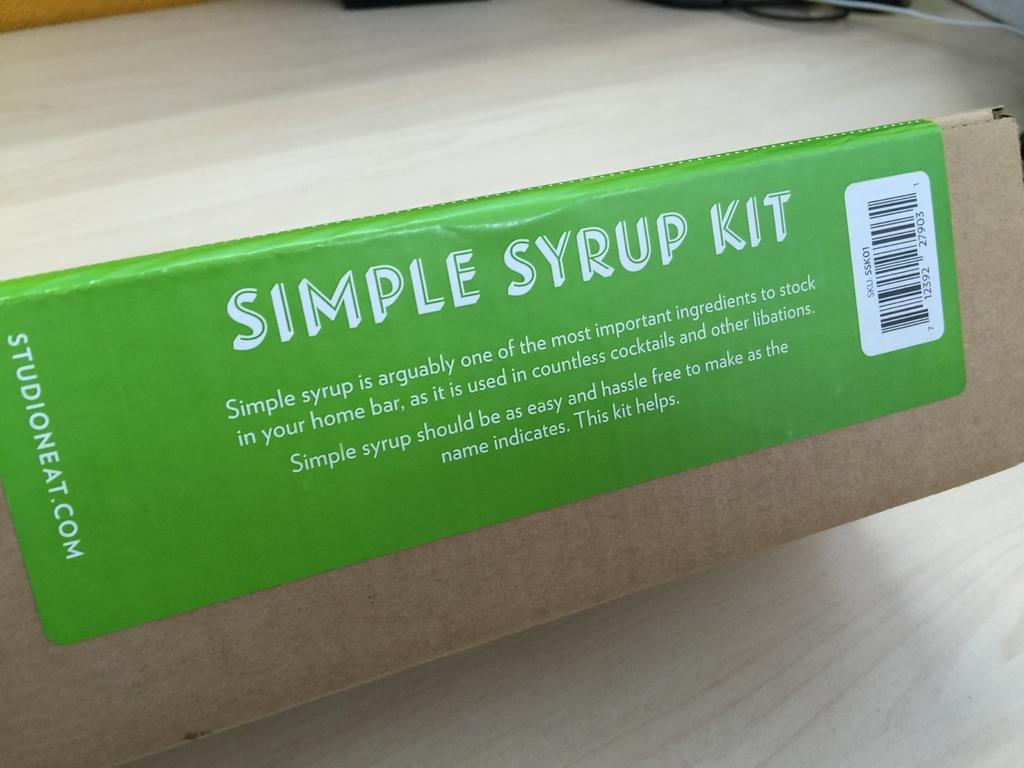<image>
Create a compact narrative representing the image presented. a green simple syrup kit that has a bar code 